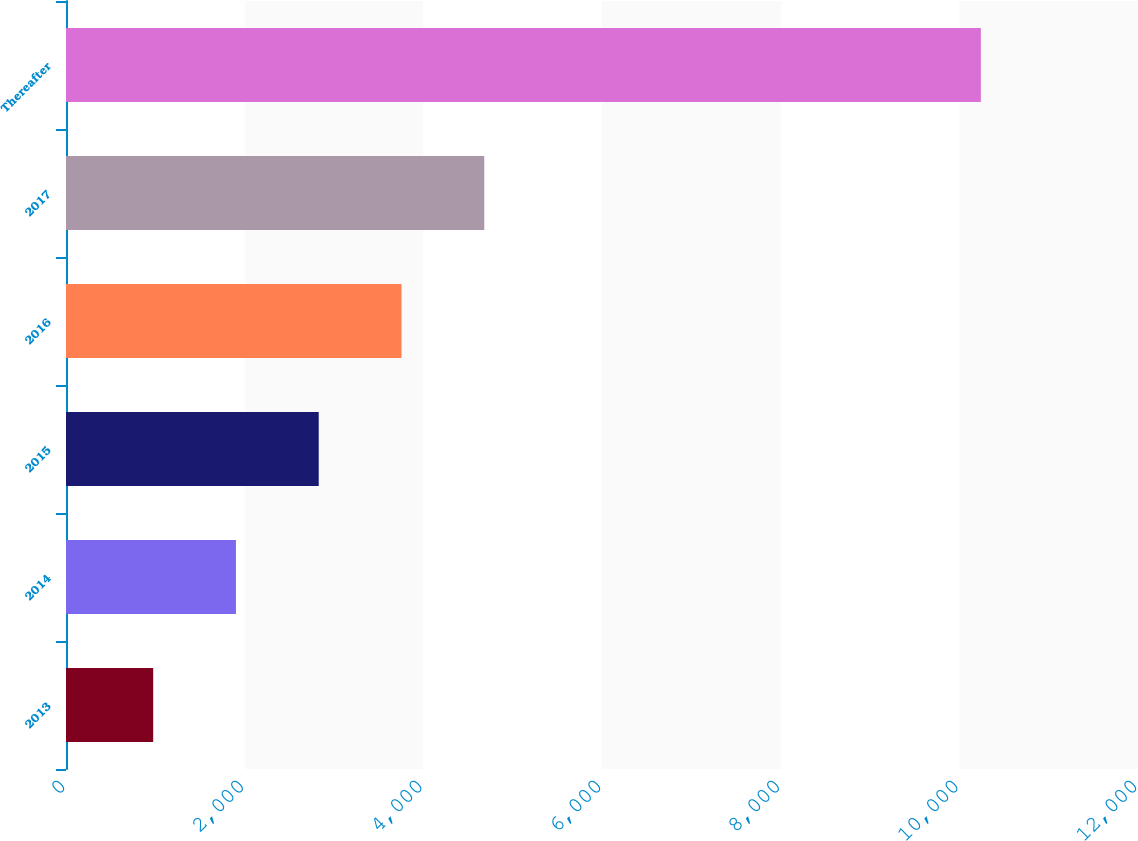Convert chart to OTSL. <chart><loc_0><loc_0><loc_500><loc_500><bar_chart><fcel>2013<fcel>2014<fcel>2015<fcel>2016<fcel>2017<fcel>Thereafter<nl><fcel>976<fcel>1902.5<fcel>2829<fcel>3755.5<fcel>4682<fcel>10241<nl></chart> 